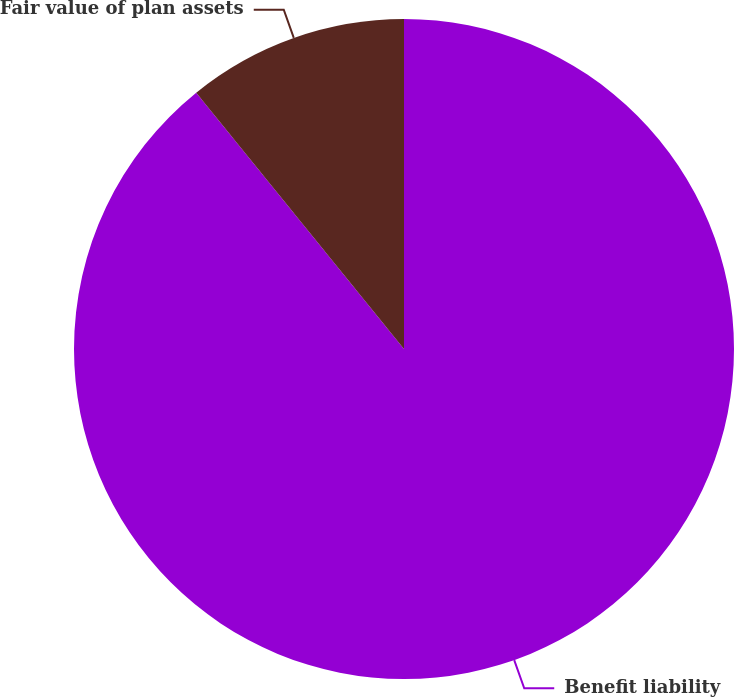Convert chart to OTSL. <chart><loc_0><loc_0><loc_500><loc_500><pie_chart><fcel>Benefit liability<fcel>Fair value of plan assets<nl><fcel>89.16%<fcel>10.84%<nl></chart> 